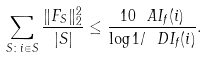Convert formula to latex. <formula><loc_0><loc_0><loc_500><loc_500>\sum _ { S \colon i \in S } \frac { \| F _ { S } \| _ { 2 } ^ { 2 } } { | S | } \leq \frac { 1 0 \ A I _ { f } ( i ) } { \log 1 / \ D I _ { f } ( i ) } .</formula> 